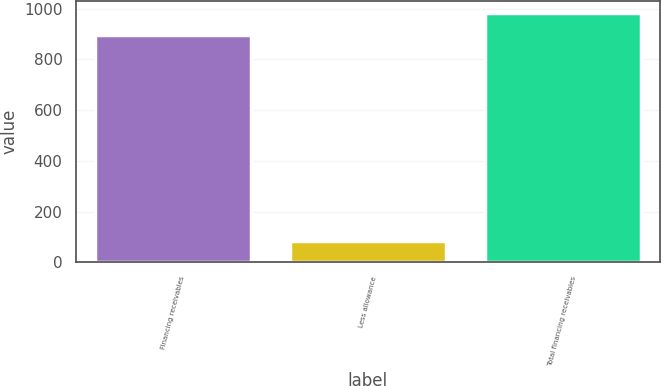<chart> <loc_0><loc_0><loc_500><loc_500><bar_chart><fcel>Financing receivables<fcel>Less allowance<fcel>Total financing receivables<nl><fcel>897<fcel>82<fcel>982.2<nl></chart> 